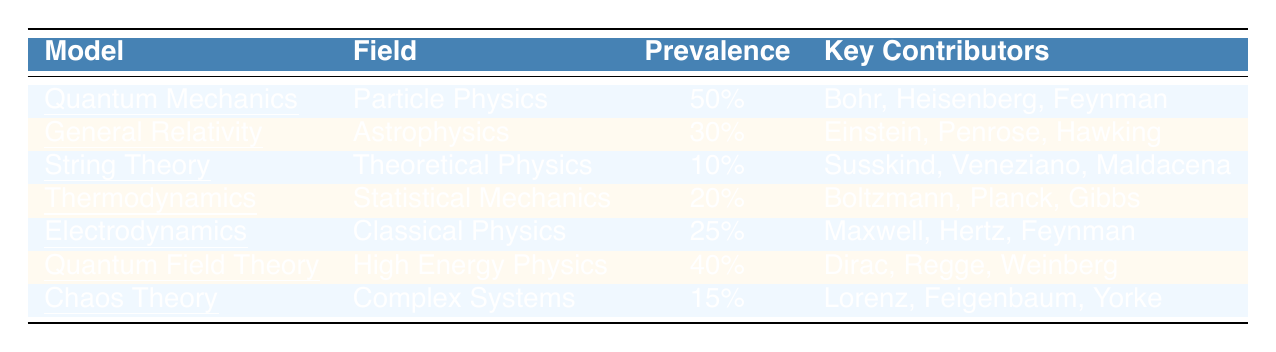What is the prevalence of Quantum Mechanics? The table lists Quantum Mechanics under the "Prevalence" column with a value of 50%.
Answer: 50% Who are the key contributors to General Relativity? The "Key Contributors" column for General Relativity includes Einstein, Penrose, and Hawking.
Answer: Einstein, Penrose, Hawking Which theoretical model has the lowest prevalence? By reviewing the "Prevalence" column, String Theory has the lowest value of 10%.
Answer: String Theory What percentage of the theoretical models belong to Statistical Mechanics? Thermodynamics is the only model listed under Statistical Mechanics, with a prevalence of 20%. So, that is 1 out of 7 total models or approximately 14.29%.
Answer: Approximately 14.29% Is the prevalence of Quantum Field Theory greater than or equal to that of Electrodynamics? Quantum Field Theory has a prevalence of 40%, while Electrodynamics has 25%. Since 40% is greater than 25%, the statement is true.
Answer: Yes What is the average prevalence of the models in Classical Physics and Statistical Mechanics? The prevalence for Electrodynamics (Classical Physics) is 25% and Thermodynamics (Statistical Mechanics) is 20%. The average is (25% + 20%) / 2 = 22.5%.
Answer: 22.5% How many key contributors are associated with Chaos Theory? The "Key Contributors" column for Chaos Theory lists three names: Lorenz, Feigenbaum, and Yorke.
Answer: 3 What is the total prevalence of all theoretical models listed in the table? Adding all prevalence values: 50% + 30% + 10% + 20% + 25% + 40% + 15% gives a total of 250%.
Answer: 250% Which model in the table is associated with the most key contributors? Reviewing the table, Quantum Mechanics and General Relativity both have three key contributors each, which is the highest.
Answer: Quantum Mechanics and General Relativity What is the difference in prevalence between Quantum Mechanics and String Theory? Quantum Mechanics has a prevalence of 50% while String Theory has 10%. The difference is 50% - 10% = 40%.
Answer: 40% 